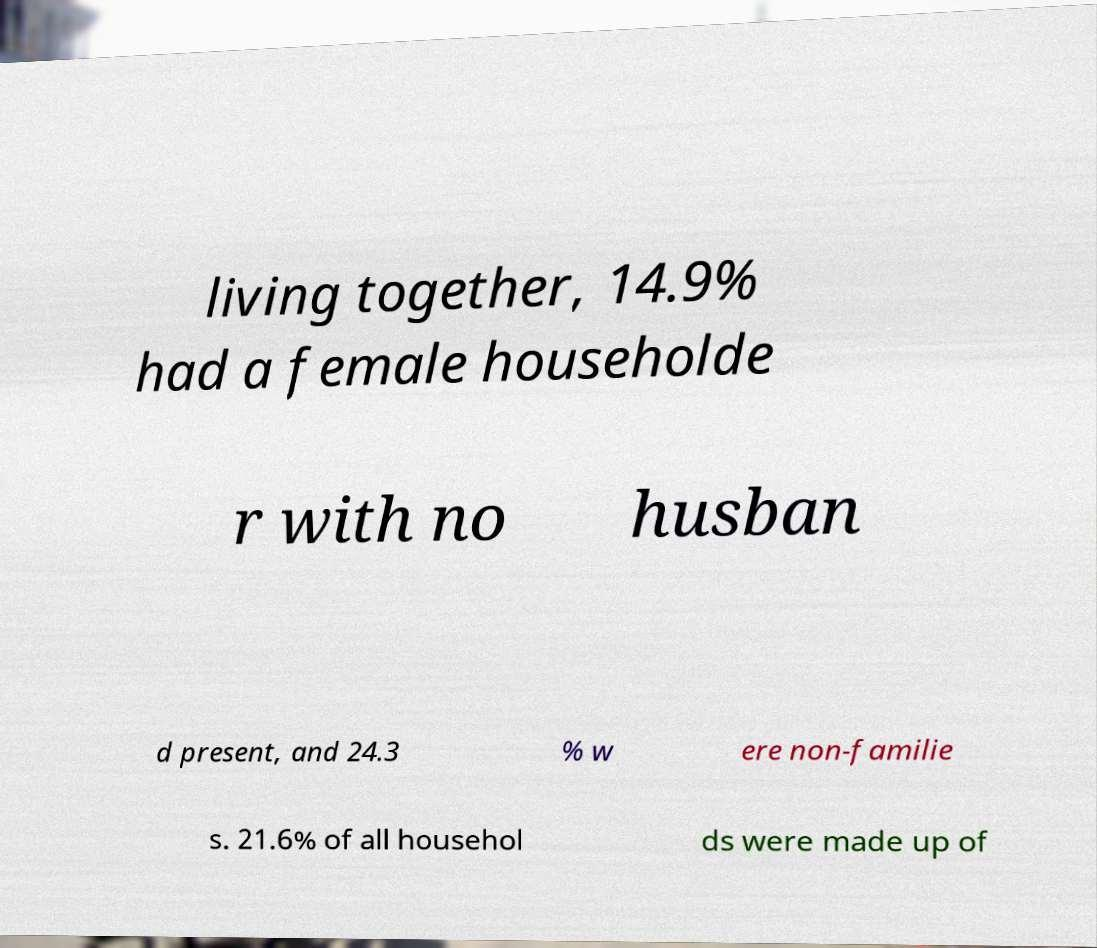There's text embedded in this image that I need extracted. Can you transcribe it verbatim? living together, 14.9% had a female householde r with no husban d present, and 24.3 % w ere non-familie s. 21.6% of all househol ds were made up of 